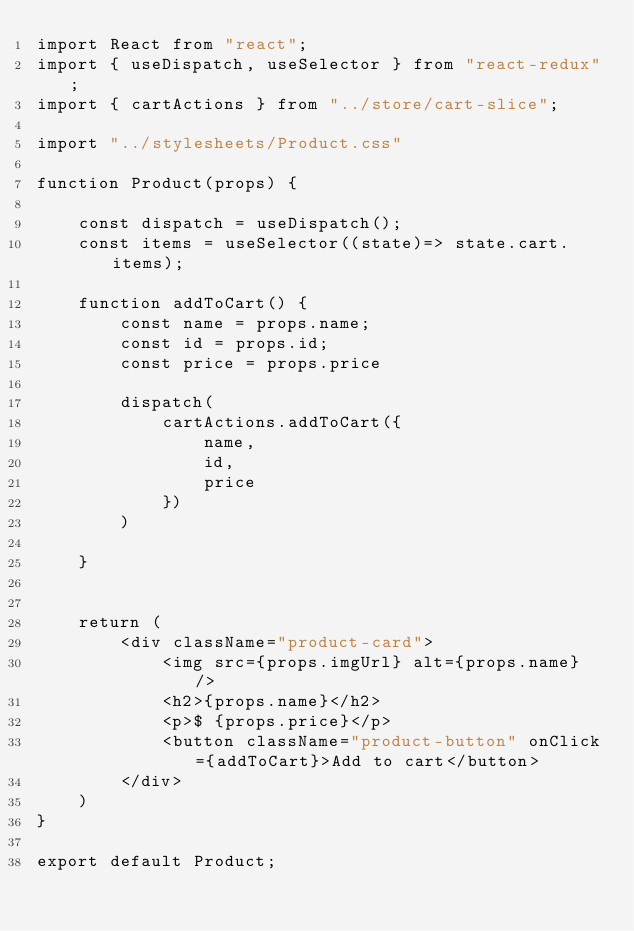Convert code to text. <code><loc_0><loc_0><loc_500><loc_500><_JavaScript_>import React from "react";
import { useDispatch, useSelector } from "react-redux";
import { cartActions } from "../store/cart-slice";

import "../stylesheets/Product.css"

function Product(props) {

    const dispatch = useDispatch();
    const items = useSelector((state)=> state.cart.items);
    
    function addToCart() {
        const name = props.name;
        const id = props.id;
        const price = props.price

        dispatch(
            cartActions.addToCart({
                name,
                id,
                price
            })
        )
         
    }


    return (
        <div className="product-card">
            <img src={props.imgUrl} alt={props.name} />
            <h2>{props.name}</h2>
            <p>$ {props.price}</p>
            <button className="product-button" onClick={addToCart}>Add to cart</button>
        </div>
    )
}

export default Product;</code> 